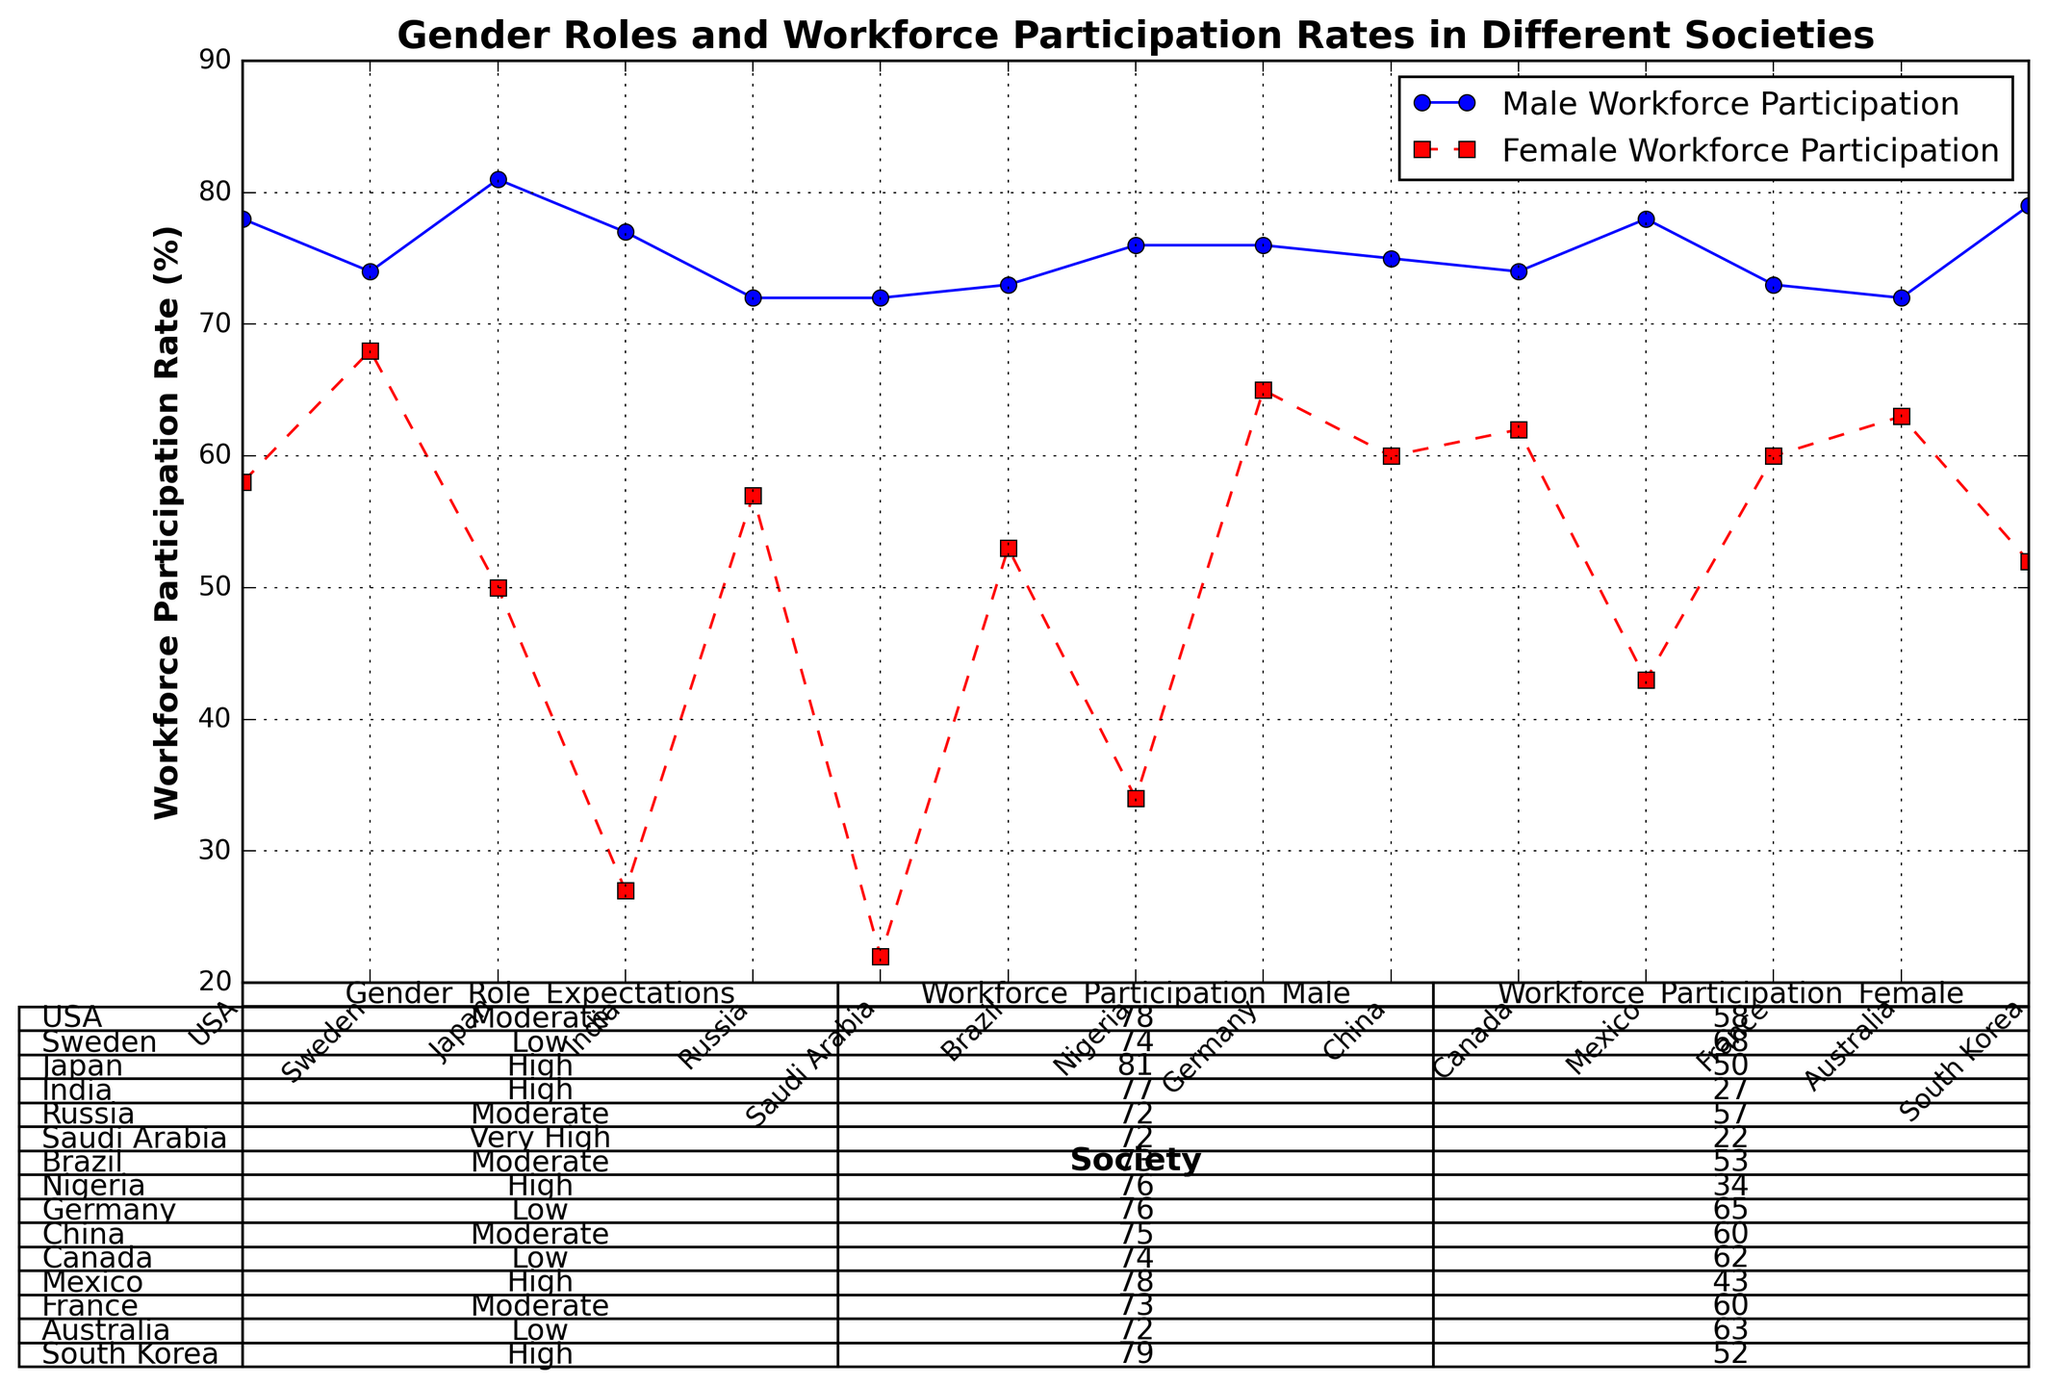What is the difference in male workforce participation between Japan and South Korea? Japan's male workforce participation is 81%, and South Korea's is 79%. The difference is 81% - 79% = 2%.
Answer: 2% Which society has the highest female workforce participation? Sweden has the highest female workforce participation at 68%, as indicated by the red markers on the plot.
Answer: Sweden Compare the female workforce participation rates between Germany and Australia. Which one is higher? Germany's female workforce participation rate is 65%, while Australia's is 63%. Therefore, Germany's rate is higher.
Answer: Germany Calculate the average workforce participation rate for females across all societies. Sum the female participation rates (58 + 68 + 50 + 27 + 57 + 22 + 53 + 34 + 65 + 60 + 62 + 43 + 60 + 63 + 52) and divide by the number of societies (15). The sum is 774, so the average is 774 / 15 = 51.6%.
Answer: 51.6% What is the median workforce participation rate for males in the given societies? Arrange the male participation rates in ascending order (72, 72, 72, 73, 73, 74, 74, 75, 76, 76, 77, 78, 78, 79, 81). The median is the middle value in this list, which is 75%.
Answer: 75% Which societies have a male workforce participation rate lower than the average male participation rate? First, calculate the average male participation rate: Sum the values (78 + 74 + 81 + 77 + 72 + 72 + 73 + 76 + 76 + 75 + 74 + 78 + 73 + 72 + 79) to get 1170, and divide by 15 to get 78.0. Societies lower than 78 are Sweden, Russia, Saudi Arabia, Brazil, Nigeria, Germany, Canada, France, and Australia.
Answer: Sweden, Russia, Saudi Arabia, Brazil, Nigeria, Germany, Canada, France, Australia What is the ratio of male to female workforce participation in India? India's male workforce participation is 77%, and female is 27%. The ratio is 77 / 27 ≈ 2.85.
Answer: 2.85 In societies with low gender role expectations, how does the average female workforce participation compare to the overall average? Low gender role expectation societies (Sweden, Germany, Canada, Australia) have female rates of 68, 65, 62, and 63. Sum is 258, and average is 258 / 4 = 64.5. Overall average is 51.6%. Thus, 64.5% is higher than 51.6%.
Answer: 64.5% is higher How much higher is female workforce participation in Canada compared to Saudi Arabia? Canada has 62% female participation, while Saudi Arabia has 22%. The difference is 62% - 22% = 40%.
Answer: 40% 